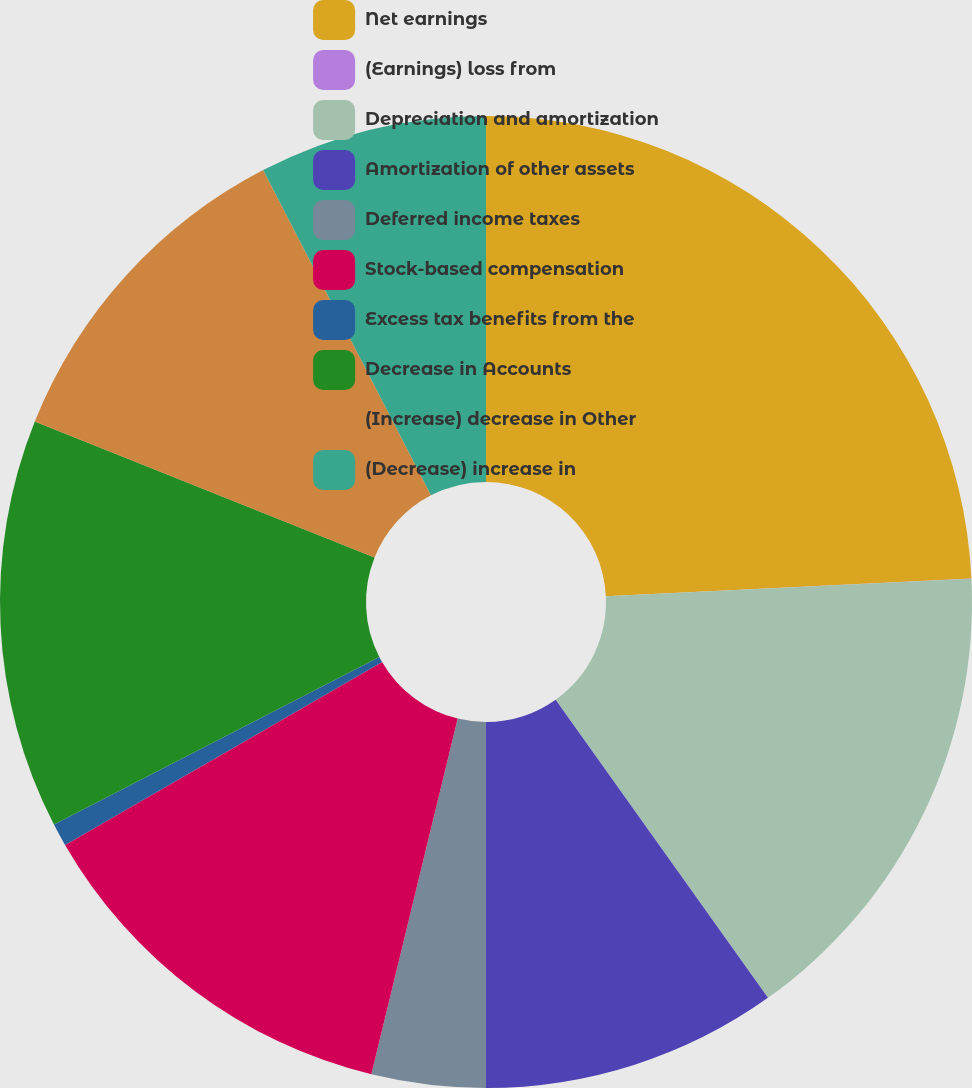Convert chart to OTSL. <chart><loc_0><loc_0><loc_500><loc_500><pie_chart><fcel>Net earnings<fcel>(Earnings) loss from<fcel>Depreciation and amortization<fcel>Amortization of other assets<fcel>Deferred income taxes<fcel>Stock-based compensation<fcel>Excess tax benefits from the<fcel>Decrease in Accounts<fcel>(Increase) decrease in Other<fcel>(Decrease) increase in<nl><fcel>24.23%<fcel>0.01%<fcel>15.91%<fcel>9.85%<fcel>3.79%<fcel>12.88%<fcel>0.76%<fcel>13.63%<fcel>11.36%<fcel>7.58%<nl></chart> 